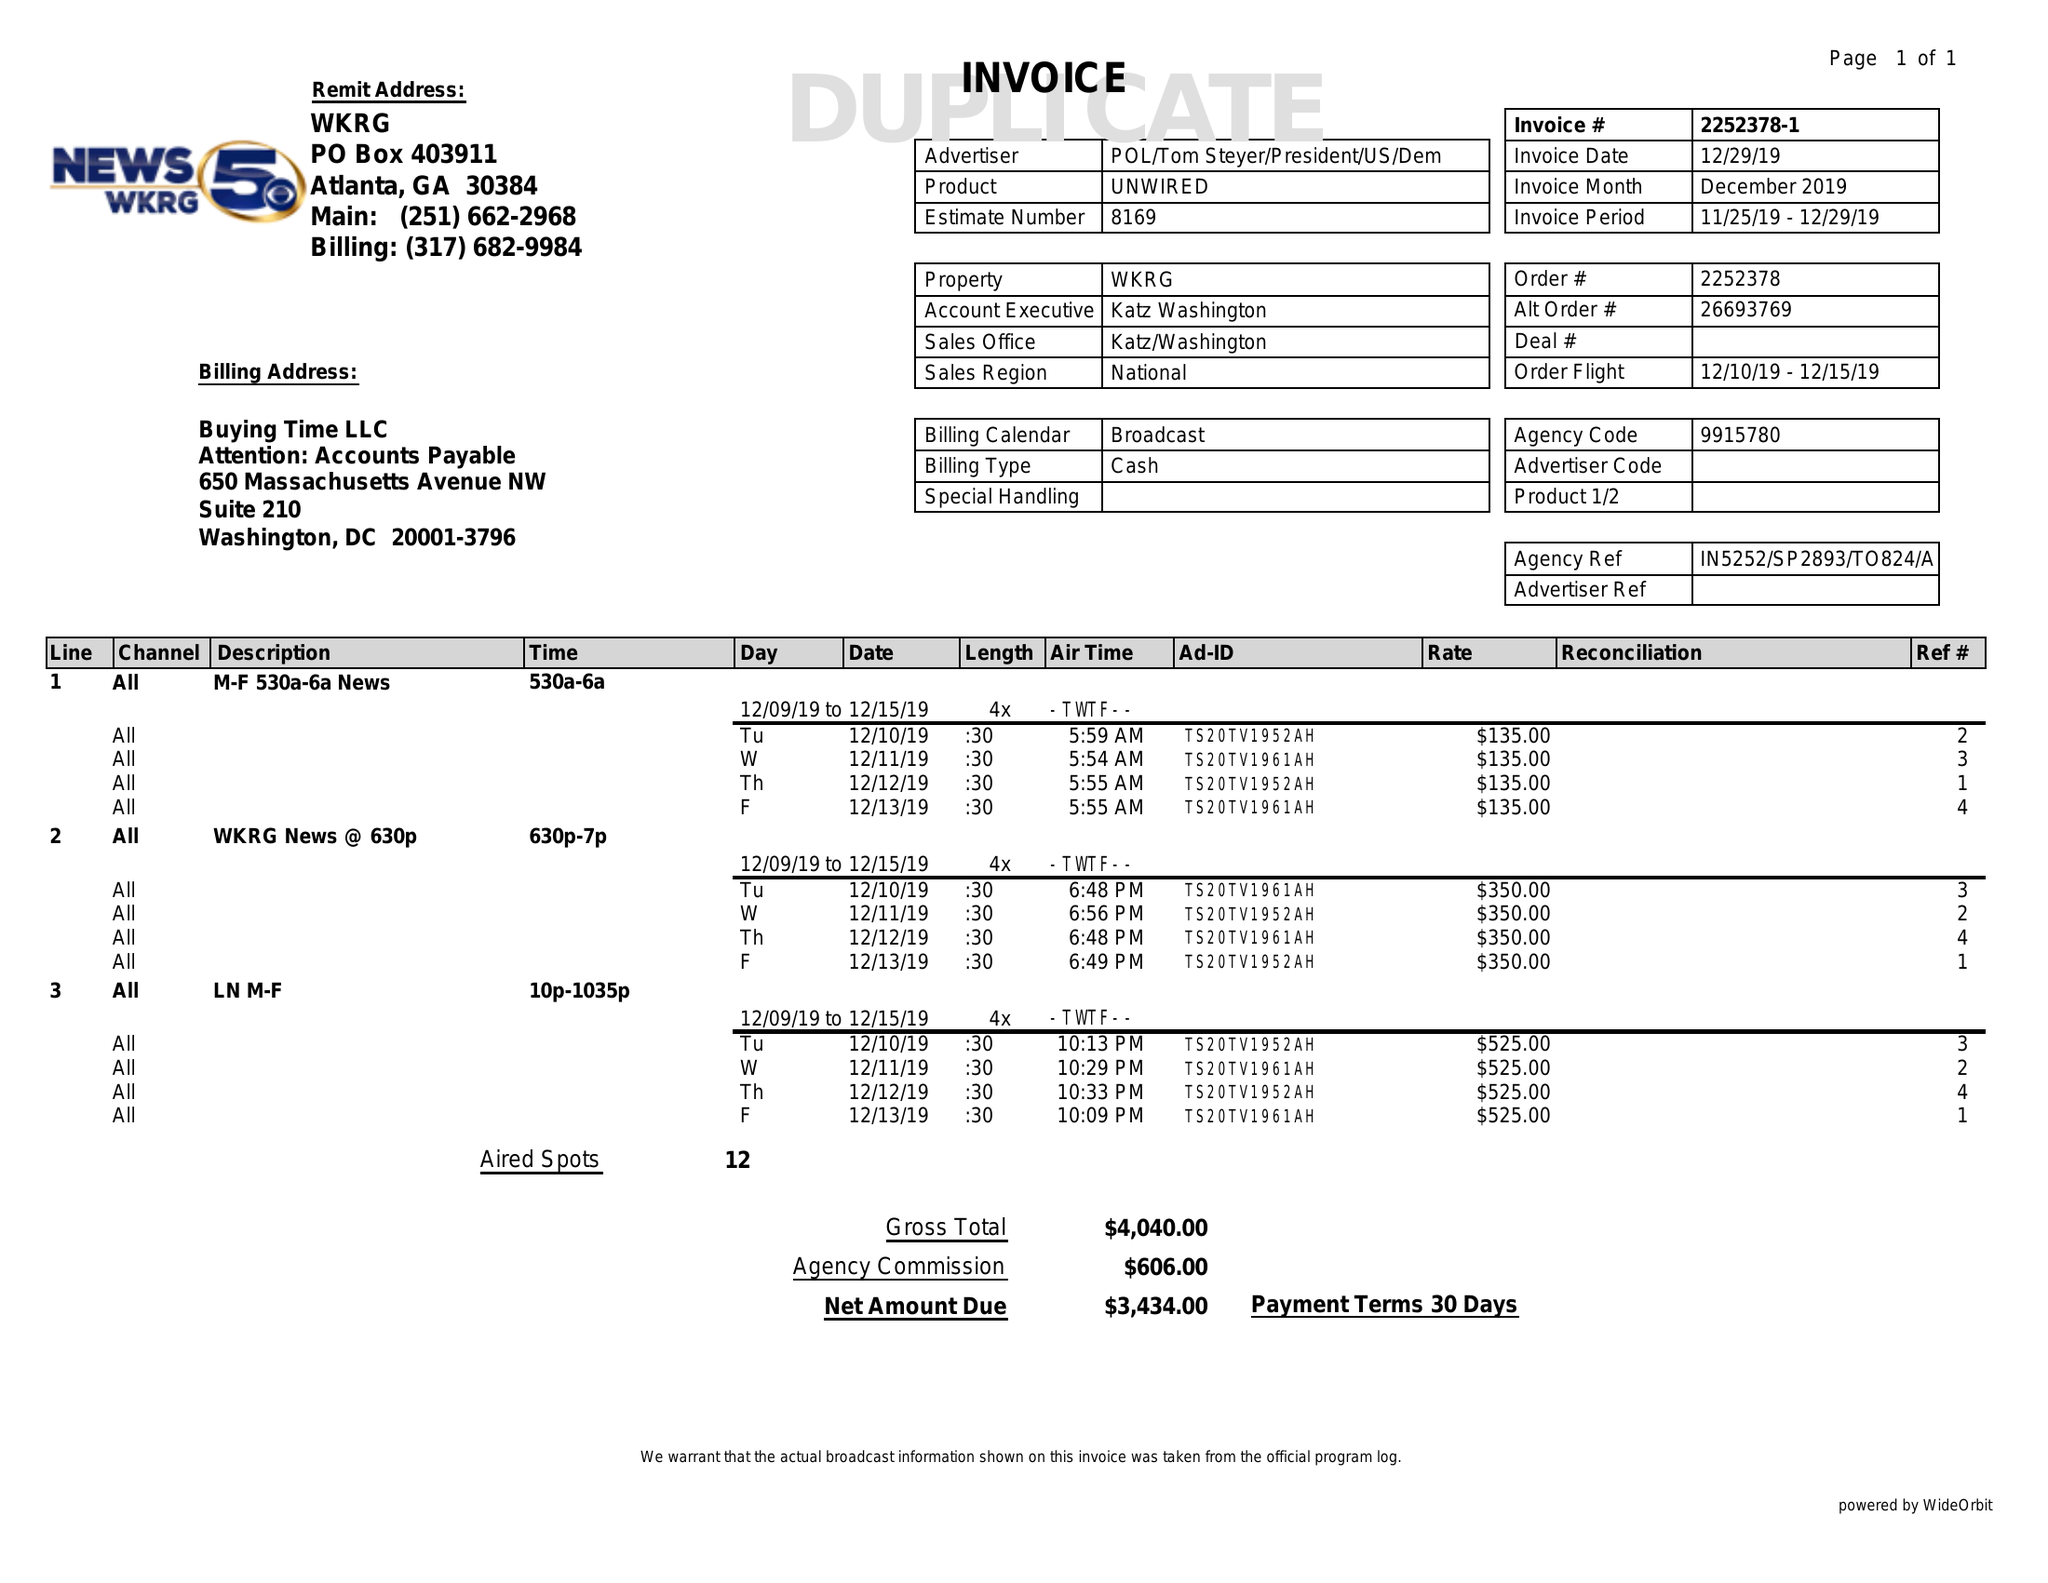What is the value for the flight_from?
Answer the question using a single word or phrase. 12/10/19 